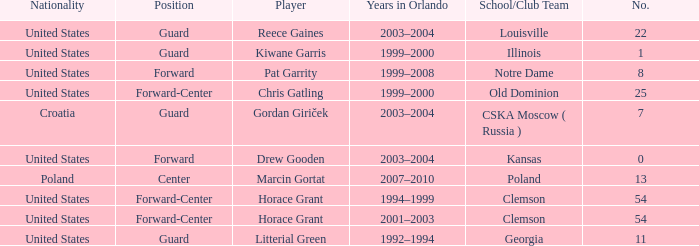What number identifies Chris Gatling? 25.0. 